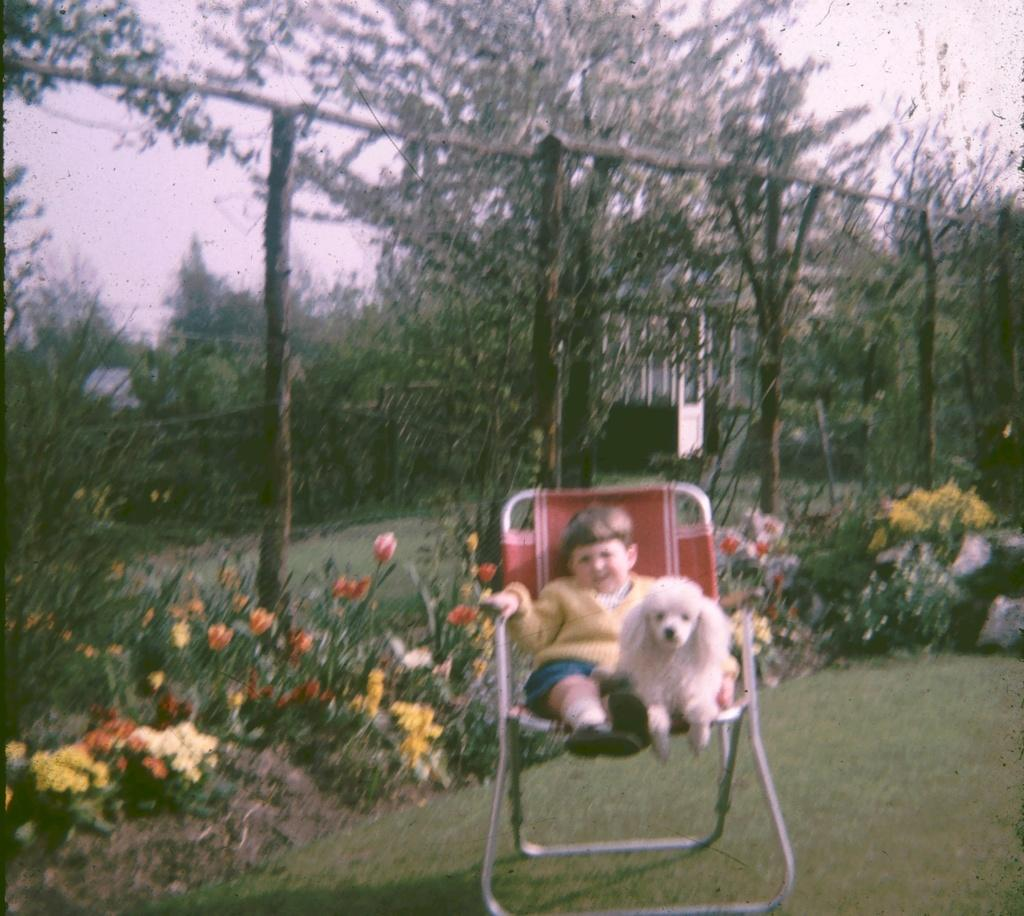Who is the main subject in the image? There is a boy in the image. What is the boy doing in the image? The boy is sitting on a chair and holding a dog. What can be seen in the background of the image? There are plants with flowers and trees in the background of the image. What is visible at the top of the image? The sky is visible at the top of the image. What type of needle is the boy using to sew a horse in the image? There is no needle or horse present in the image. What is the boy's wealth status in the image? The image does not provide any information about the boy's wealth status. 